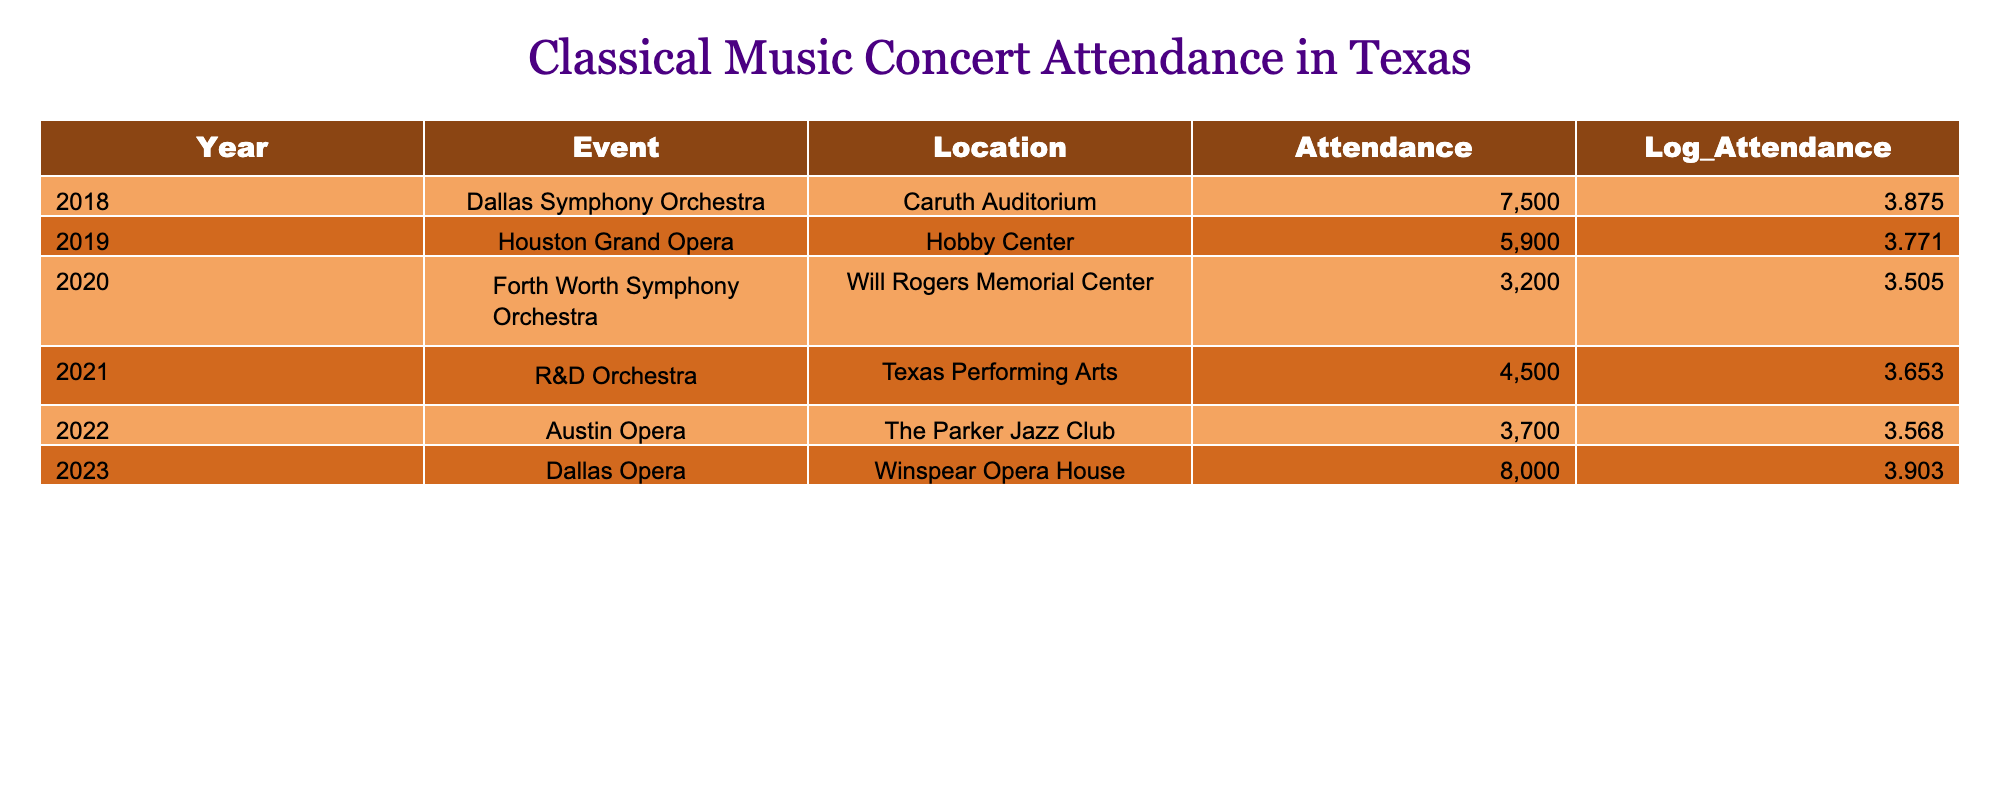What was the attendance at the Dallas Opera in 2023? The table lists the year, event, location, and attendance. Looking at the 2023 row, it specifies "Dallas Opera" with attendance of 8000.
Answer: 8000 Which event had the lowest attendance in Texas among the years listed? Examining the table, the row for the "Fort Worth Symphony Orchestra" in 2020 shows attendance of 3200, which is less than any other row's attendance figures.
Answer: 3200 What is the total attendance across all the events from 2018 to 2023? Adding the attendance figures together: 7500 + 5900 + 3200 + 4500 + 3700 + 8000 gives a total of 28800.
Answer: 28800 Did the attendance for the Houston Grand Opera in 2019 exceed 6000? The attendance for the Houston Grand Opera listed in the table is 5900, which is less than 6000. Therefore, the answer is no.
Answer: No What was the average attendance at the concerts in 2022 and 2023? The attendance figures for those years are 3700 (2022) and 8000 (2023). Averaging these values: (3700 + 8000) / 2 = 5850.
Answer: 5850 Was the attendance at the R&D Orchestra in 2021 greater than the average attendance for the years 2018-2023? First, calculate the average attendance for all years: (7500 + 5900 + 3200 + 4500 + 3700 + 8000) / 6 = 4800. The attendance for R&D Orchestra was 4500, which is less than the average.
Answer: No How many events had an attendance of 5000 or more? Looking through the table: "Dallas Symphony Orchestra" (7500), "Houston Grand Opera" (5900), "Dallas Opera" (8000) are all 5000 or more, totaling three events.
Answer: 3 What is the difference in attendance between the Dallas Symphony Orchestra in 2018 and the Austin Opera in 2022? The attendance for Dallas Symphony Orchestra is 7500, and for Austin Opera, it is 3700. The difference is 7500 - 3700 = 3800.
Answer: 3800 Which concert location had the highest attendance? When reviewing the table, the "Winspear Opera House" for the Dallas Opera event in 2023 has the highest attendance figure of 8000.
Answer: Winspear Opera House 